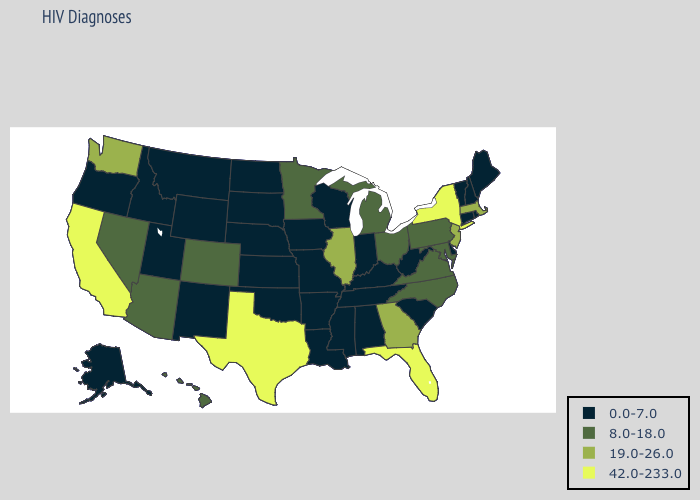What is the value of Alabama?
Write a very short answer. 0.0-7.0. What is the value of Missouri?
Give a very brief answer. 0.0-7.0. Does the map have missing data?
Short answer required. No. Does Hawaii have the highest value in the USA?
Concise answer only. No. Among the states that border North Carolina , does Tennessee have the lowest value?
Write a very short answer. Yes. Is the legend a continuous bar?
Answer briefly. No. What is the highest value in states that border New Mexico?
Short answer required. 42.0-233.0. What is the value of Delaware?
Quick response, please. 0.0-7.0. Is the legend a continuous bar?
Keep it brief. No. Does Mississippi have the same value as Alabama?
Write a very short answer. Yes. What is the lowest value in the USA?
Give a very brief answer. 0.0-7.0. Does the first symbol in the legend represent the smallest category?
Concise answer only. Yes. What is the highest value in the West ?
Quick response, please. 42.0-233.0. Among the states that border Louisiana , which have the lowest value?
Answer briefly. Arkansas, Mississippi. 